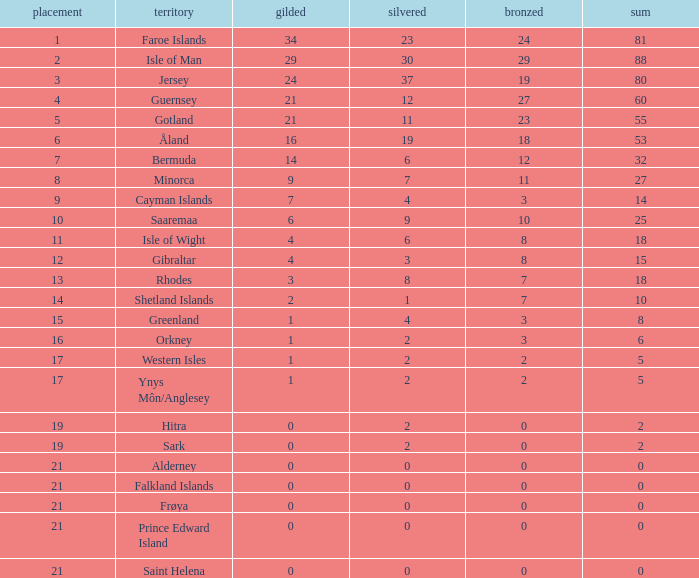How many Silver medals were won in total by all those with more than 3 bronze and exactly 16 gold? 19.0. 